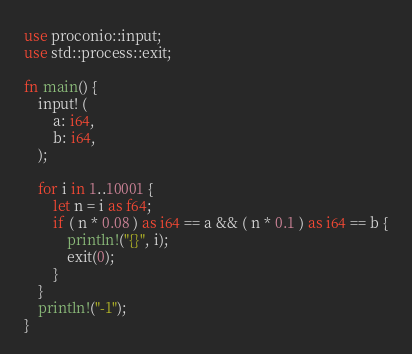<code> <loc_0><loc_0><loc_500><loc_500><_Rust_>use proconio::input;
use std::process::exit;

fn main() {
    input! (
        a: i64,
        b: i64,
    );

    for i in 1..10001 {
        let n = i as f64;
        if ( n * 0.08 ) as i64 == a && ( n * 0.1 ) as i64 == b {
            println!("{}", i);
            exit(0);
        }
    }
    println!("-1");
}
</code> 